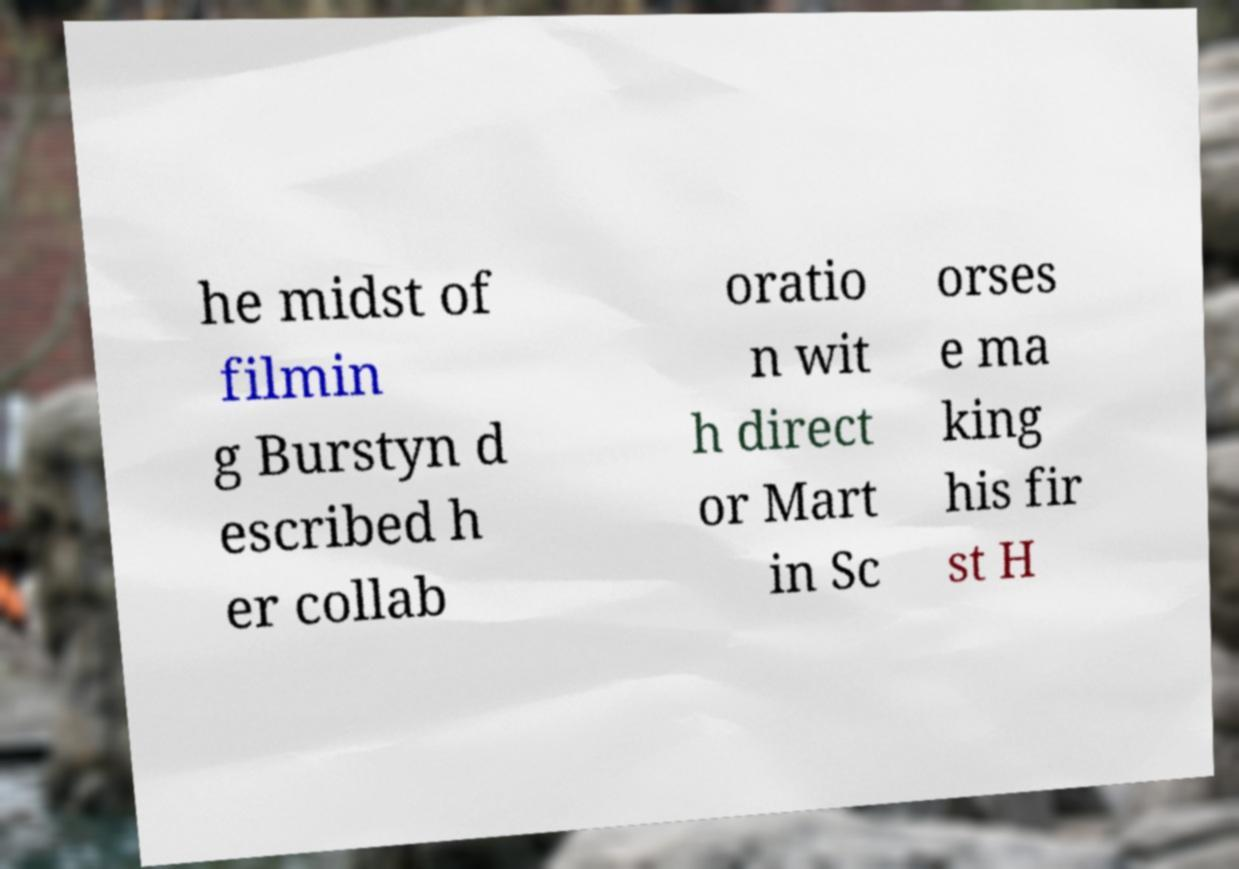There's text embedded in this image that I need extracted. Can you transcribe it verbatim? he midst of filmin g Burstyn d escribed h er collab oratio n wit h direct or Mart in Sc orses e ma king his fir st H 